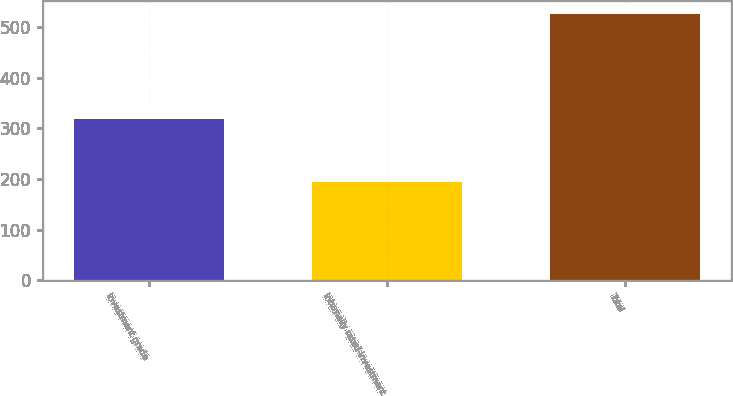Convert chart to OTSL. <chart><loc_0><loc_0><loc_500><loc_500><bar_chart><fcel>Investment grade<fcel>Internally rated-investment<fcel>Total<nl><fcel>319<fcel>193<fcel>525<nl></chart> 